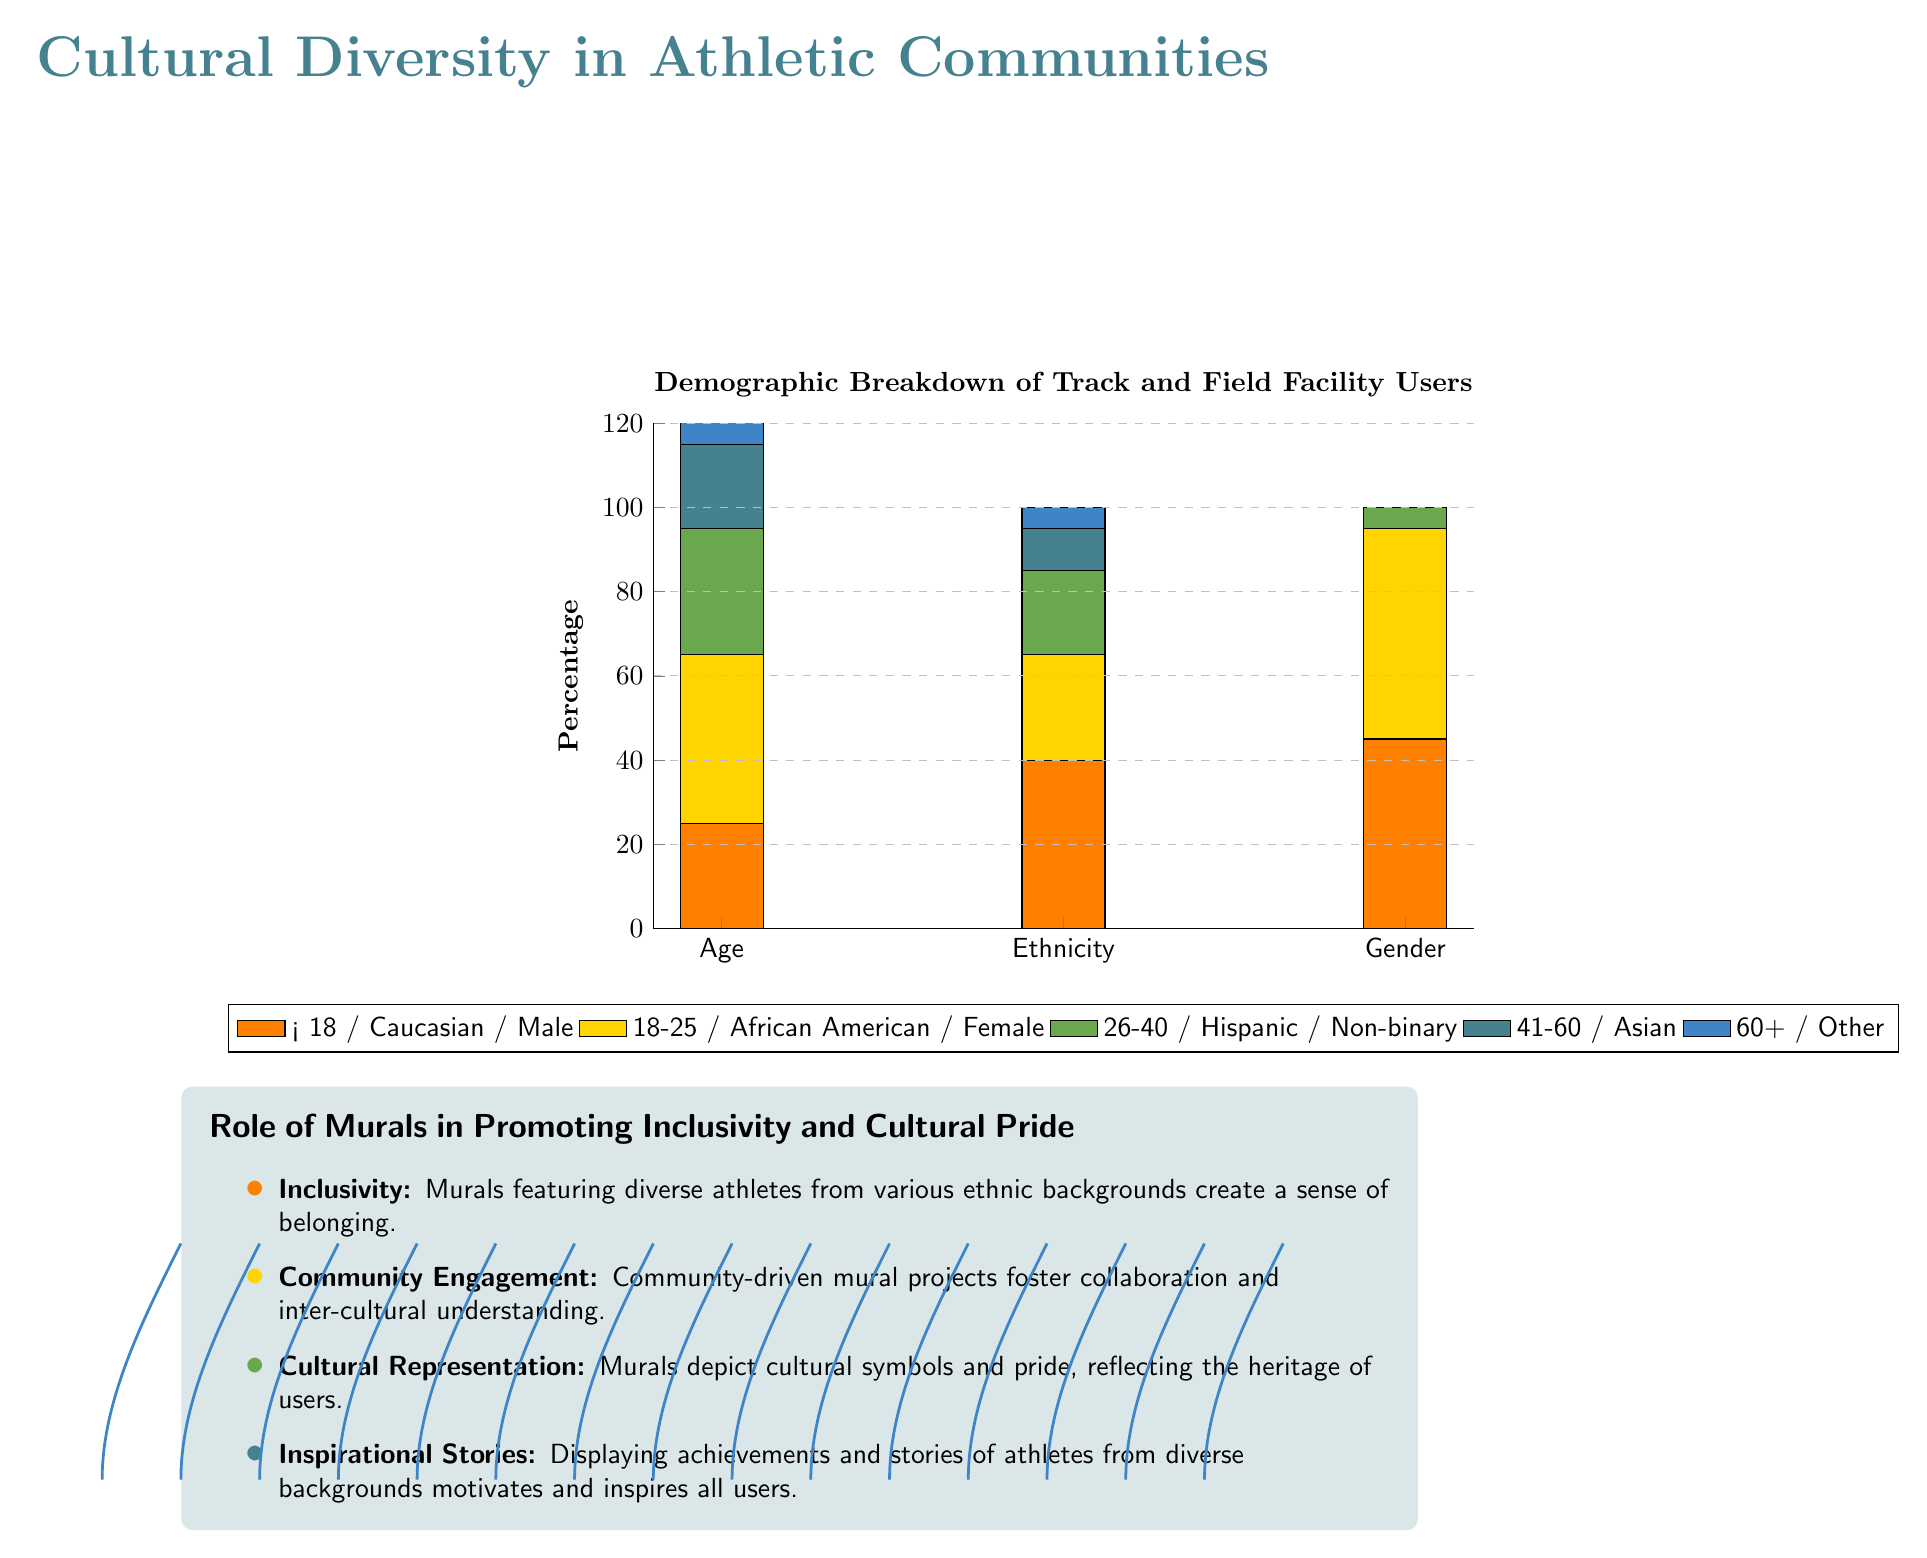What percentage of users are aged 18-25? In the stacked bar chart under the age group section, you can see the orange bar representing the percentage of users aged 18-25 is at 40%.
Answer: 40% Which ethnicity has the highest representation in male track and field users? By looking at the gender section of the stacked bar chart, the blue bar representing Caucasian males is the highest, at 45%.
Answer: Caucasian What is the total percentage of users aged 60 and older? To find the percentage of users in the age group 60+ in the stacked bar chart, you can simply observe the contributions: 10% from the orange (Caucasian) and 0% from the others, which equals 10%.
Answer: 10% How many different sections are represented in the demographic breakdown? The x-axis of the stacked bar chart shows three distinct sections: Age, Ethnicity, and Gender, which indicates there are three different sections portrayed in the demographic breakdown.
Answer: Three What role do murals play in promoting cultural representation according to the infographic? The infographic states that murals depict cultural symbols and pride, reflecting the heritage of users, which emphasizes the importance of visuals in conveying cultural representation.
Answer: Cultural representation Which age group has the least percentage of users? In the age section of the stacked bar chart, the age group 41-60 has the smallest orange bar, which shows 20%, making it the least percentage of users.
Answer: 41-60: 20% What are integrative themes identified for murals in promoting inclusivity? Analyzing the infographic, the themes include inclusivity, community engagement, cultural representation, and inspirational stories, which are collectively emphasized to showcase the role of murals.
Answer: Inclusivity, community engagement, cultural representation, inspirational stories Which gender has a total percentage representation of zero in the demographic breakdown? Referring to the Gender section of the stacked bar chart, the green bar for Non-binary shows a total of 0% representation.
Answer: Non-binary 